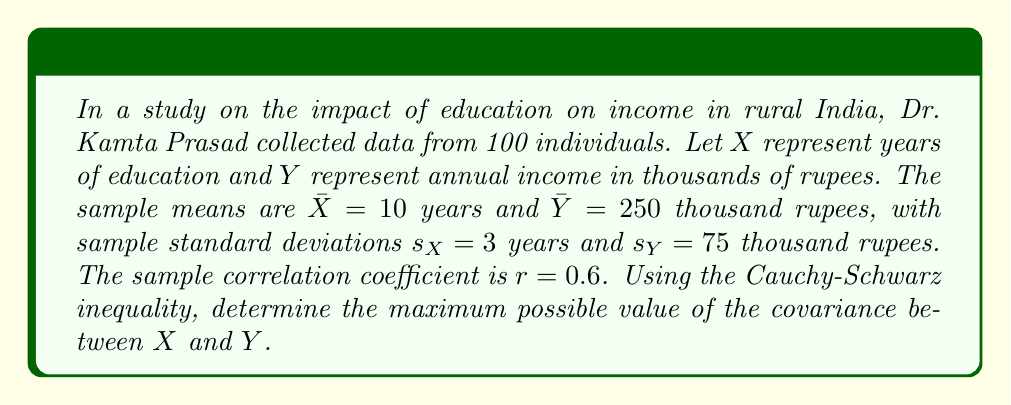What is the answer to this math problem? To solve this problem, we'll use the Cauchy-Schwarz inequality and its relationship to correlation and covariance in statistical analysis:

1) The Cauchy-Schwarz inequality states that:
   $$(E[XY])^2 \leq E[X^2]E[Y^2]$$

2) In terms of covariance and variance, this can be written as:
   $$(\text{Cov}(X,Y))^2 \leq \text{Var}(X)\text{Var}(Y)$$

3) The correlation coefficient $r$ is defined as:
   $$r = \frac{\text{Cov}(X,Y)}{s_X s_Y}$$

4) Rearranging this, we get:
   $$\text{Cov}(X,Y) = r s_X s_Y$$

5) We're given $r = 0.6$, $s_X = 3$, and $s_Y = 75$. Let's calculate the covariance:
   $$\text{Cov}(X,Y) = 0.6 \times 3 \times 75 = 135$$

6) The Cauchy-Schwarz inequality tells us that this covariance is less than or equal to the maximum possible covariance. The maximum occurs when there's perfect correlation ($r = 1$):
   $$\text{Cov}(X,Y)_{\text{max}} = s_X s_Y = 3 \times 75 = 225$$

Therefore, the maximum possible value of the covariance between $X$ and $Y$ is 225.
Answer: 225 